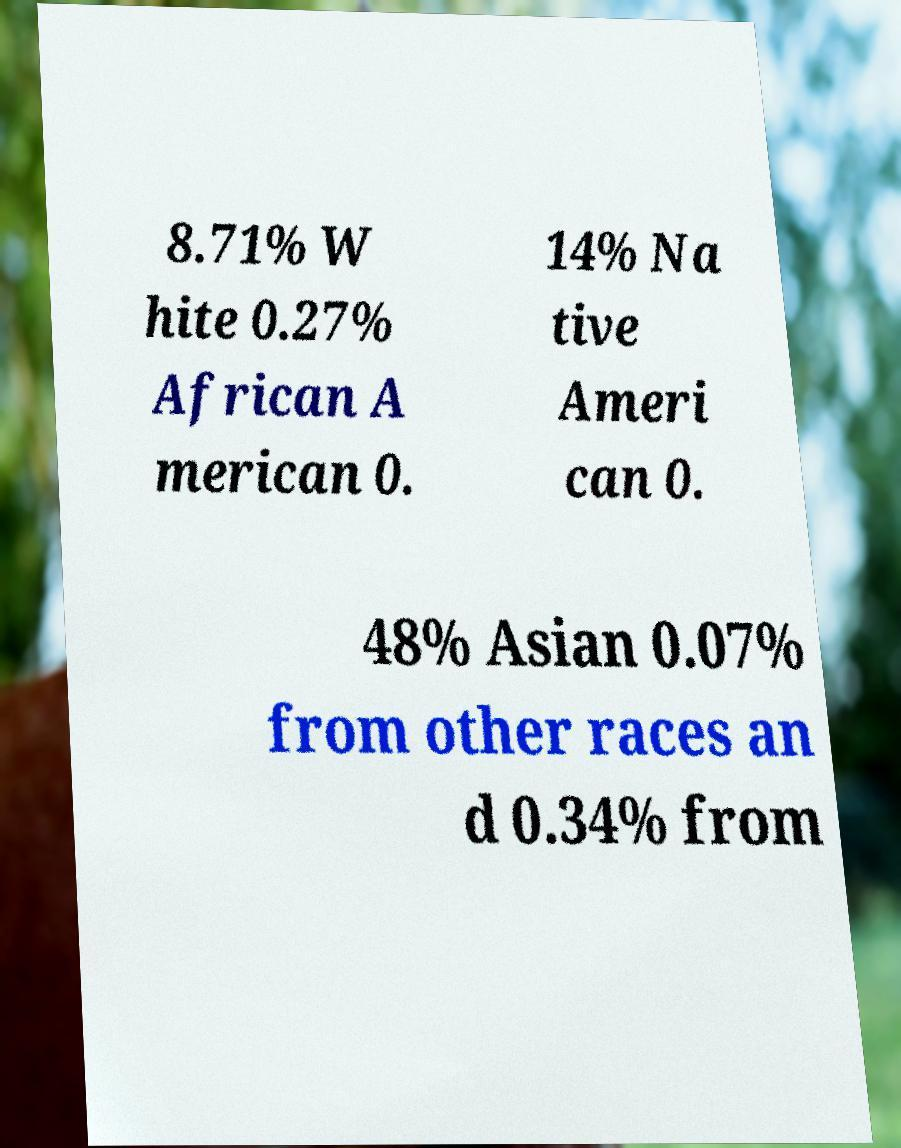For documentation purposes, I need the text within this image transcribed. Could you provide that? 8.71% W hite 0.27% African A merican 0. 14% Na tive Ameri can 0. 48% Asian 0.07% from other races an d 0.34% from 